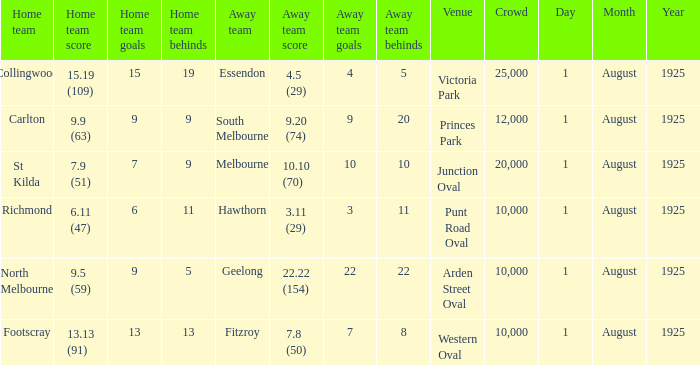Which match where Hawthorn was the away team had the largest crowd? 10000.0. Give me the full table as a dictionary. {'header': ['Home team', 'Home team score', 'Home team goals', 'Home team behinds', 'Away team', 'Away team score', 'Away team goals', 'Away team behinds', 'Venue', 'Crowd', 'Day', 'Month', 'Year'], 'rows': [['Collingwood', '15.19 (109)', '15', '19', 'Essendon', '4.5 (29)', '4', '5', 'Victoria Park', '25,000', '1', 'August', '1925'], ['Carlton', '9.9 (63)', '9', '9', 'South Melbourne', '9.20 (74)', '9', '20', 'Princes Park', '12,000', '1', 'August', '1925'], ['St Kilda', '7.9 (51)', '7', '9', 'Melbourne', '10.10 (70)', '10', '10', 'Junction Oval', '20,000', '1', 'August', '1925'], ['Richmond', '6.11 (47)', '6', '11', 'Hawthorn', '3.11 (29)', '3', '11', 'Punt Road Oval', '10,000', '1', 'August', '1925'], ['North Melbourne', '9.5 (59)', '9', '5', 'Geelong', '22.22 (154)', '22', '22', 'Arden Street Oval', '10,000', '1', 'August', '1925'], ['Footscray', '13.13 (91)', '13', '13', 'Fitzroy', '7.8 (50)', '7', '8', 'Western Oval', '10,000', '1', 'August', '1925']]} 